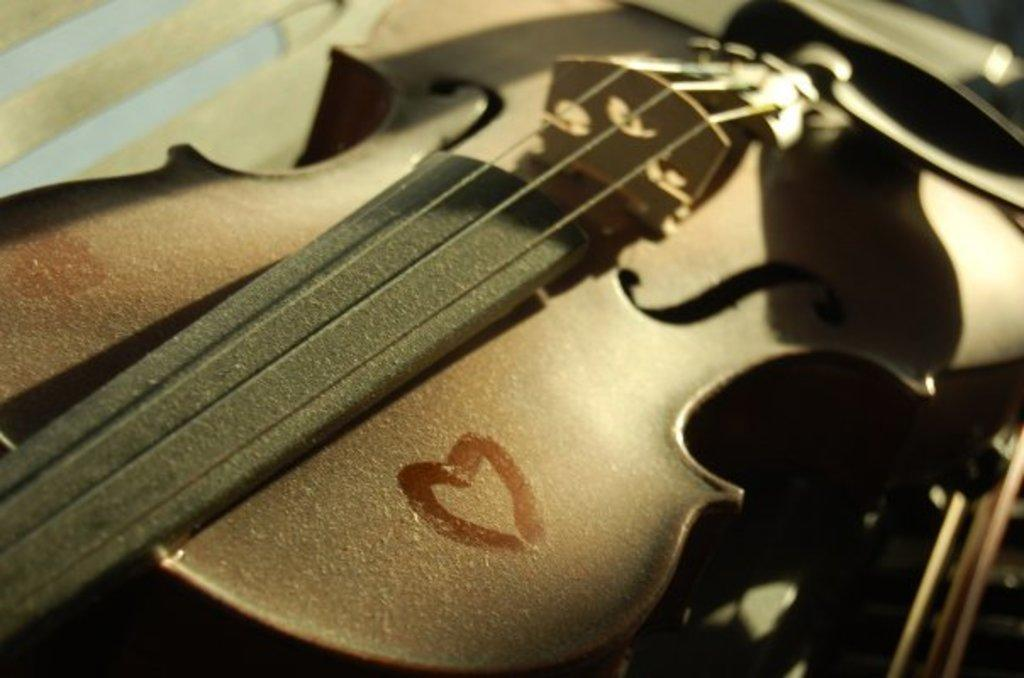What musical instrument is present in the image? There is a guitar in the image. Can you describe the guitar in the image? The image shows a guitar, but it does not provide any specific details about its appearance or condition. What type of cap is being worn by the guitar in the image? There is no cap present in the image, as the subject is a guitar, which is an inanimate object and cannot wear a cap. 